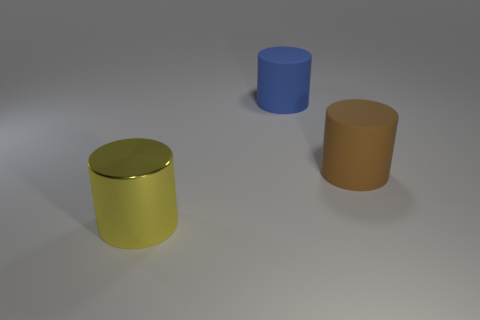Add 2 tiny blue matte cylinders. How many objects exist? 5 Subtract 0 gray cubes. How many objects are left? 3 Subtract all yellow shiny objects. Subtract all yellow objects. How many objects are left? 1 Add 2 yellow things. How many yellow things are left? 3 Add 1 blue rubber things. How many blue rubber things exist? 2 